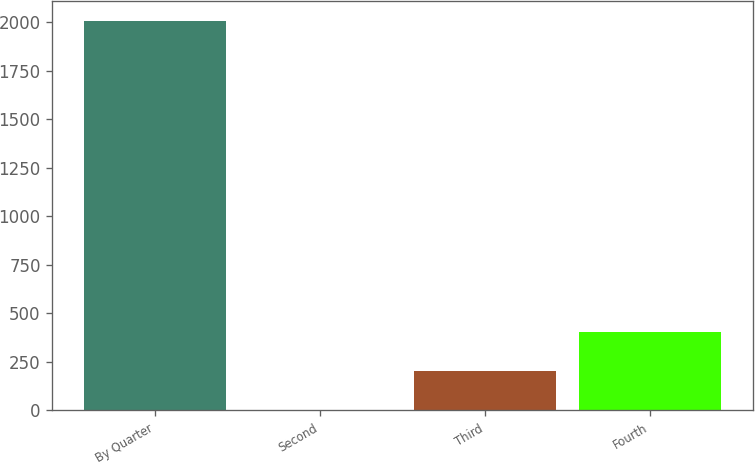Convert chart. <chart><loc_0><loc_0><loc_500><loc_500><bar_chart><fcel>By Quarter<fcel>Second<fcel>Third<fcel>Fourth<nl><fcel>2008<fcel>0.28<fcel>201.05<fcel>401.82<nl></chart> 